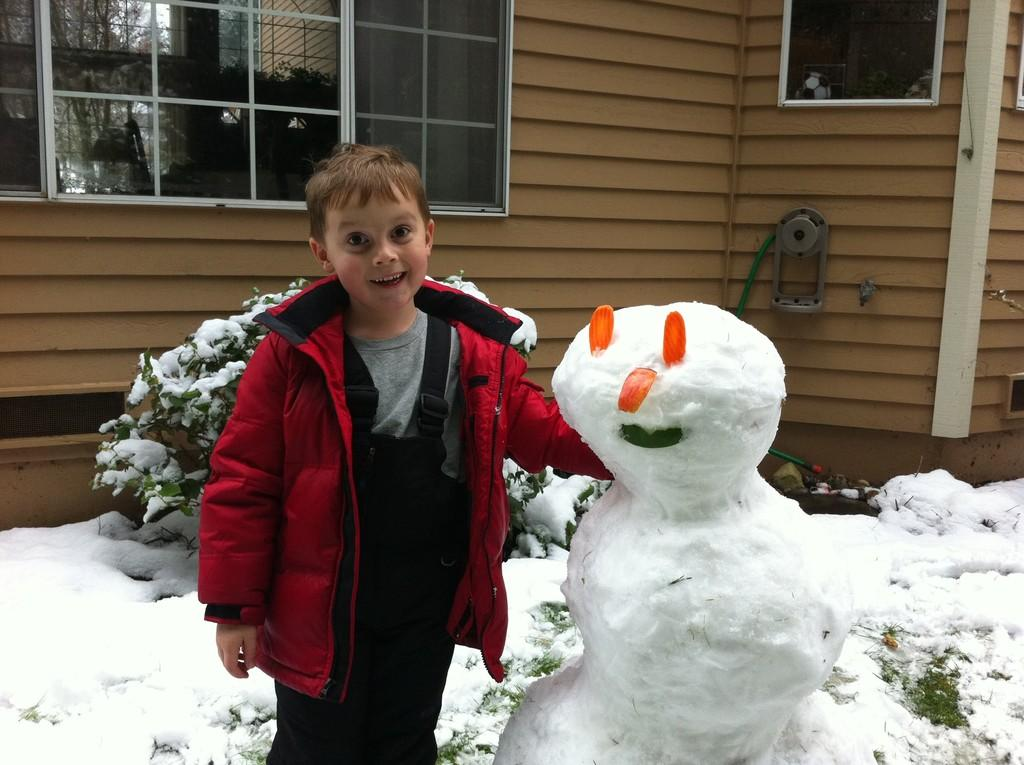What is the main subject in the center of the image? There is a boy and a snowman in the center of the image. What can be seen in the background of the image? There is a house in the background of the image. Can you describe any other elements in the image? There is a shrub fully covered with snow in the image. What type of window can be seen on the stove in the image? There is no stove or window present in the image. 